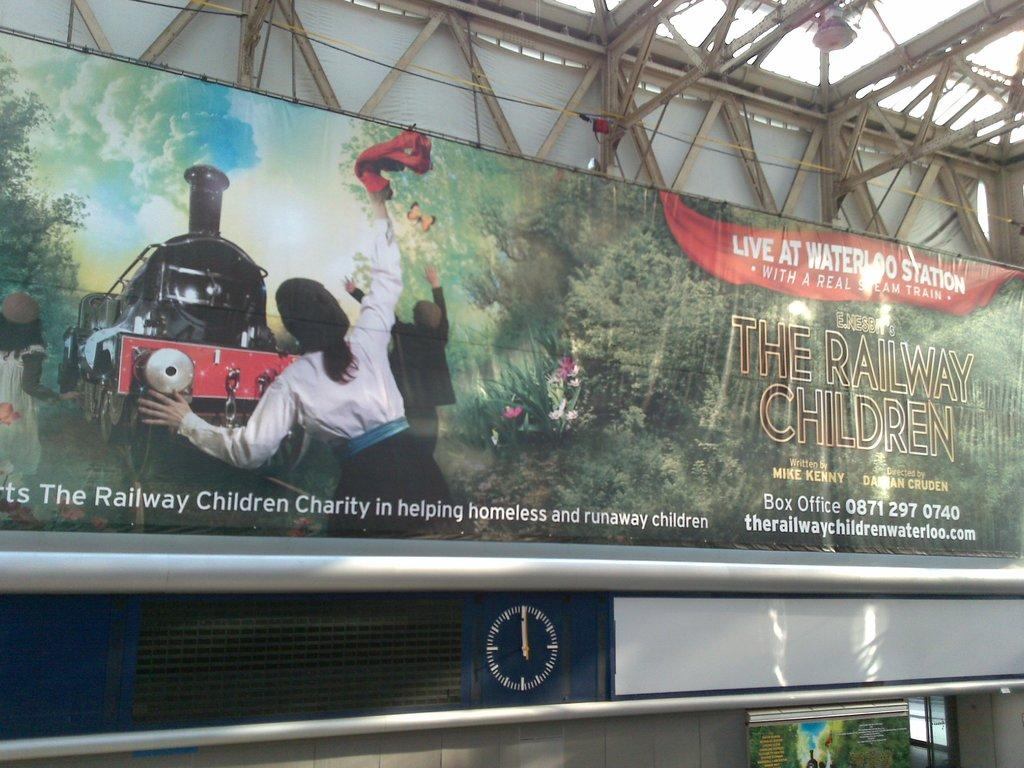<image>
Write a terse but informative summary of the picture. an advertisement with a train running over someone for waterloo station 